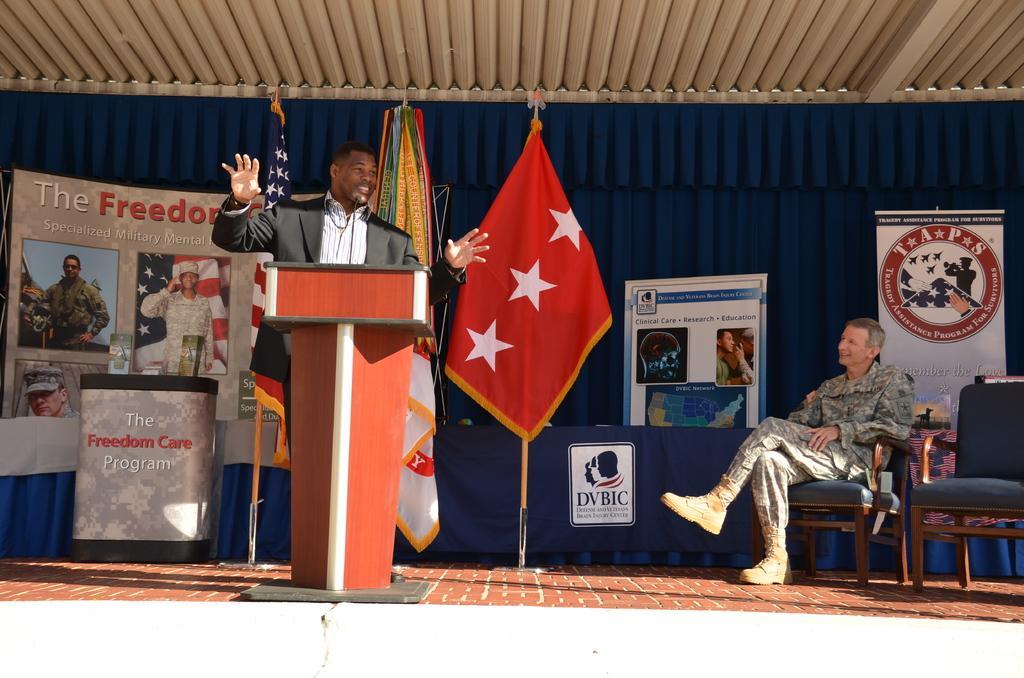How would you summarize this image in a sentence or two? This image consist of two men. To the left, the man standing near the podium is talking. To the right, the man wearing a army dress is sitting in a chair. In the background, there is a blue color cloth on which banners are fixed. In the middle there is a red flag. 